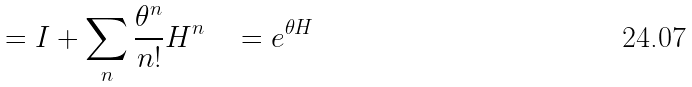Convert formula to latex. <formula><loc_0><loc_0><loc_500><loc_500>= I + \sum _ { n } \frac { { \theta } ^ { n } } { n ! } H ^ { n } \quad = e ^ { \theta H }</formula> 